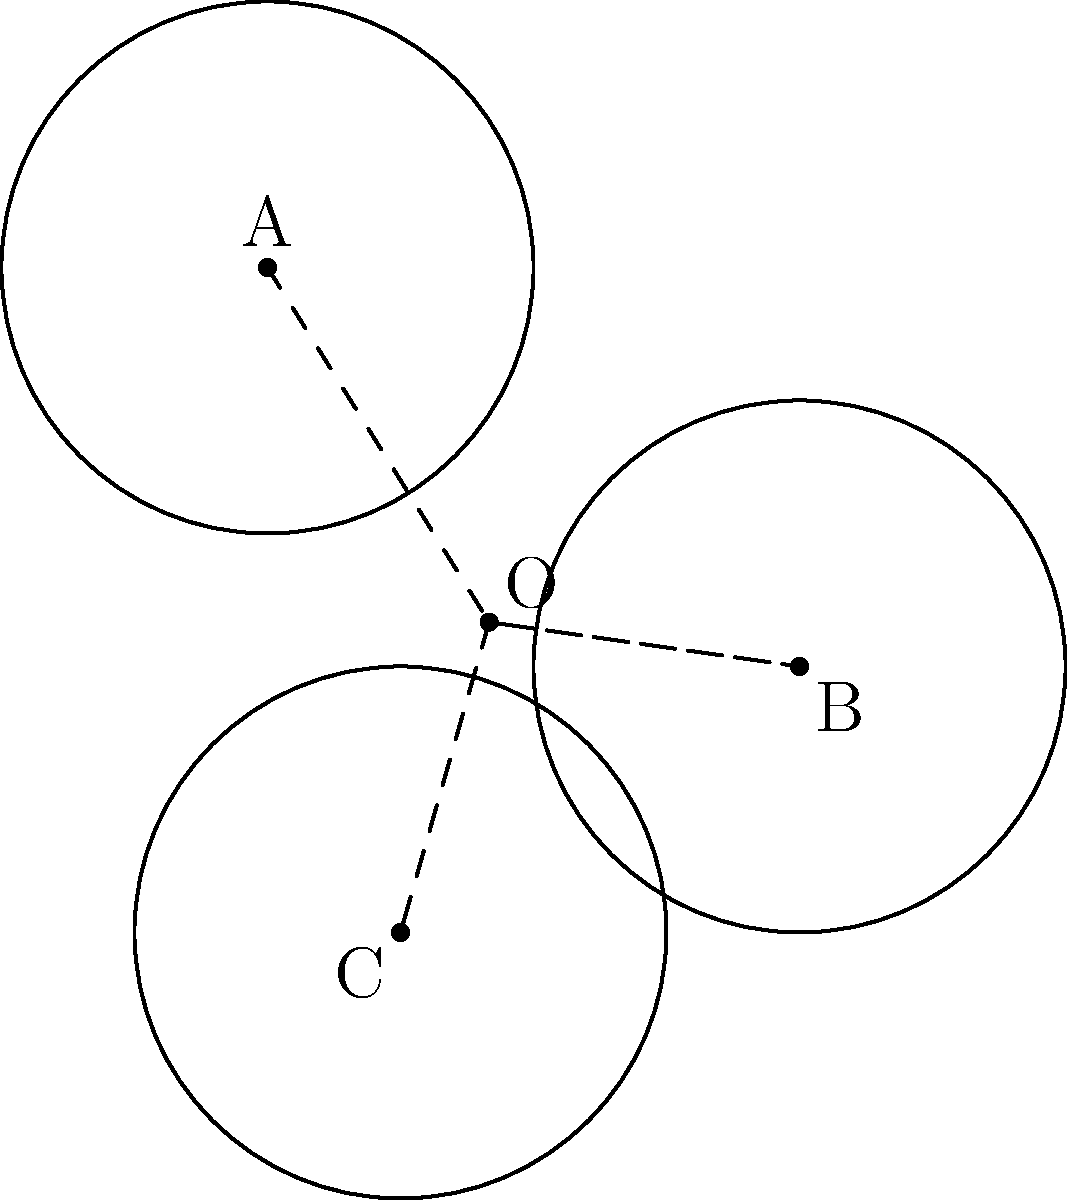In the diagram above, three circles are drawn with centers at points A(0,3), B(4,0), and C(1,-2). These circles represent three key premises in a philosophical argument. The point where these premises converge to form the core of the argument is represented by the center of a circle that passes through all three points. Using the method of coordinate geometry, find the coordinates of this central point O, which symbolizes the essence of Professor Burch's philosophical reasoning. To find the center of the circle passing through points A, B, and C, we'll use the perpendicular bisector method:

1) First, let's find the midpoint of AB and AC:
   Midpoint of AB: $M_{AB} = (\frac{0+4}{2}, \frac{3+0}{2}) = (2, \frac{3}{2})$
   Midpoint of AC: $M_{AC} = (\frac{0+1}{2}, \frac{3-2}{2}) = (\frac{1}{2}, \frac{1}{2})$

2) Now, we need to find the slopes of AB and AC:
   Slope of AB: $m_{AB} = \frac{0-3}{4-0} = -\frac{3}{4}$
   Slope of AC: $m_{AC} = \frac{-2-3}{1-0} = -5$

3) The perpendicular bisectors will have slopes that are negative reciprocals of these:
   Slope of perpendicular bisector of AB: $m_{1} = \frac{4}{3}$
   Slope of perpendicular bisector of AC: $m_{2} = \frac{1}{5}$

4) We can now write equations for these perpendicular bisectors:
   Line 1: $y - \frac{3}{2} = \frac{4}{3}(x - 2)$
   Line 2: $y - \frac{1}{2} = \frac{1}{5}(x - \frac{1}{2})$

5) The intersection of these lines will give us the center. Let's solve these equations:
   $\frac{3}{2} + \frac{4}{3}(x - 2) = \frac{1}{2} + \frac{1}{5}(x - \frac{1}{2})$
   $\frac{3}{2} + \frac{4x}{3} - \frac{8}{3} = \frac{1}{2} + \frac{x}{5} - \frac{1}{10}$
   $\frac{4x}{3} - \frac{7}{6} = \frac{x}{5} - \frac{1}{10}$
   $\frac{20x}{15} - \frac{35}{30} = \frac{3x}{15} - \frac{3}{30}$
   $17x - 35 = 3x - 3$
   $14x = 32$
   $x = \frac{16}{7} = \frac{5}{3}$

6) Substituting this x-value back into either of the line equations:
   $y - \frac{3}{2} = \frac{4}{3}(\frac{5}{3} - 2)$
   $y - \frac{3}{2} = \frac{4}{3}(-\frac{1}{3}) = -\frac{4}{9}$
   $y = \frac{3}{2} - \frac{4}{9} = \frac{27}{18} - \frac{8}{18} = \frac{19}{18} = \frac{1}{3}$

Therefore, the center of the circle, representing the core of the philosophical argument, is at the point $(\frac{5}{3}, \frac{1}{3})$.
Answer: $(\frac{5}{3}, \frac{1}{3})$ 